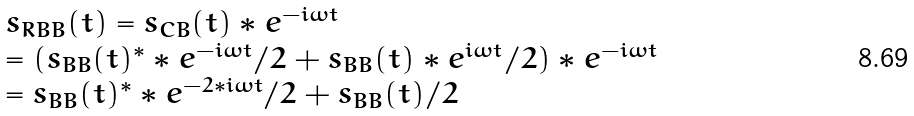Convert formula to latex. <formula><loc_0><loc_0><loc_500><loc_500>\begin{array} { l } { s _ { R B B } } ( t ) = { s _ { C B } } ( t ) * { e ^ { - i \omega t } } \\ = ( { s _ { B B } } { ( t ) ^ { * } } * { e ^ { - i \omega t } } / 2 + { s _ { B B } } ( t ) * { e ^ { i \omega t } } / 2 ) * { e ^ { - i \omega t } } \\ = { s _ { B B } } { ( t ) ^ { * } } * { e ^ { - 2 * i \omega t } } / 2 + { s _ { B B } } ( t ) / 2 \\ \end{array}</formula> 